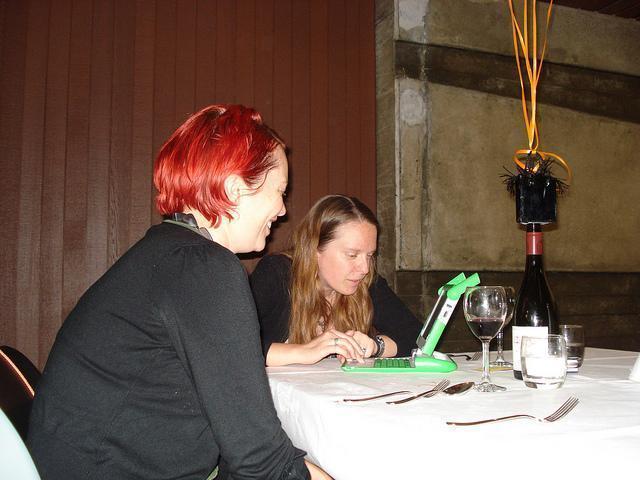Which process has been performed on the closer lady's hair?
Pick the right solution, then justify: 'Answer: answer
Rationale: rationale.'
Options: Dying, braiding, perming, shaving completely. Answer: dying.
Rationale: The hair is a little bright to be a natural color. 